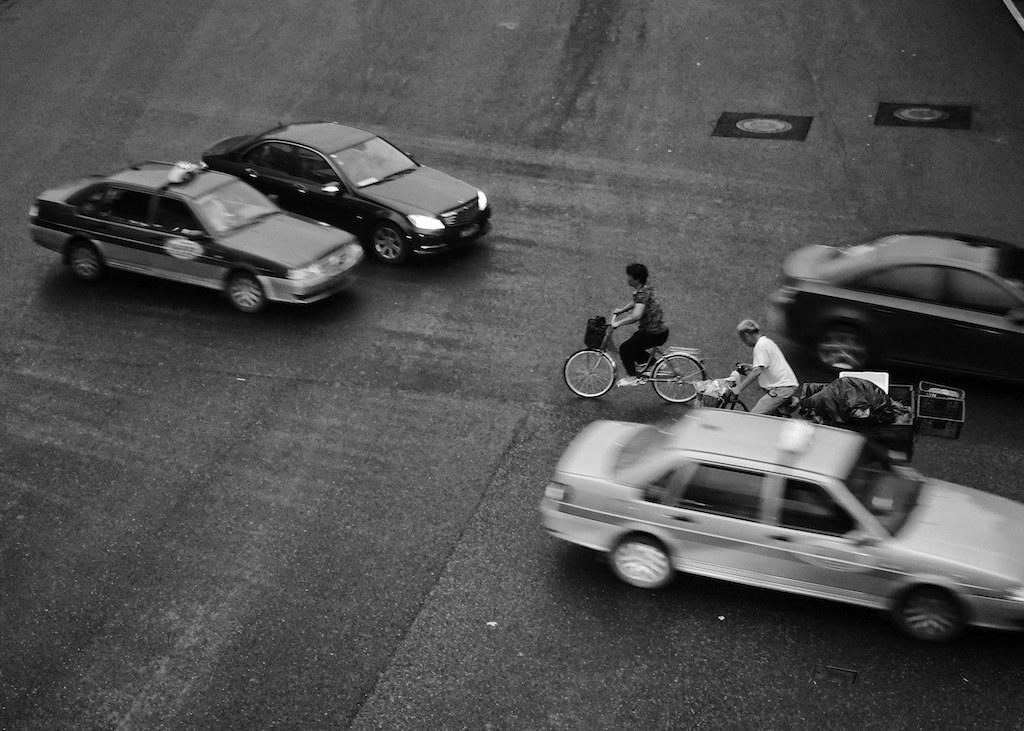What is happening on the road in the image? Vehicles are moving on the road in the image. Can you describe the people in the image? There are two people riding bicycles in the image. What type of gold stick is being exchanged between the two people riding bicycles in the image? There is no gold stick or exchange of any kind depicted in the image; it only shows two people riding bicycles and vehicles moving on the road. 